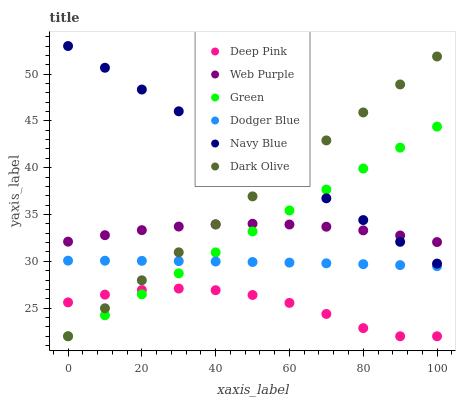Does Deep Pink have the minimum area under the curve?
Answer yes or no. Yes. Does Navy Blue have the maximum area under the curve?
Answer yes or no. Yes. Does Dark Olive have the minimum area under the curve?
Answer yes or no. No. Does Dark Olive have the maximum area under the curve?
Answer yes or no. No. Is Green the smoothest?
Answer yes or no. Yes. Is Deep Pink the roughest?
Answer yes or no. Yes. Is Navy Blue the smoothest?
Answer yes or no. No. Is Navy Blue the roughest?
Answer yes or no. No. Does Deep Pink have the lowest value?
Answer yes or no. Yes. Does Navy Blue have the lowest value?
Answer yes or no. No. Does Navy Blue have the highest value?
Answer yes or no. Yes. Does Dark Olive have the highest value?
Answer yes or no. No. Is Dodger Blue less than Web Purple?
Answer yes or no. Yes. Is Navy Blue greater than Deep Pink?
Answer yes or no. Yes. Does Dark Olive intersect Dodger Blue?
Answer yes or no. Yes. Is Dark Olive less than Dodger Blue?
Answer yes or no. No. Is Dark Olive greater than Dodger Blue?
Answer yes or no. No. Does Dodger Blue intersect Web Purple?
Answer yes or no. No. 